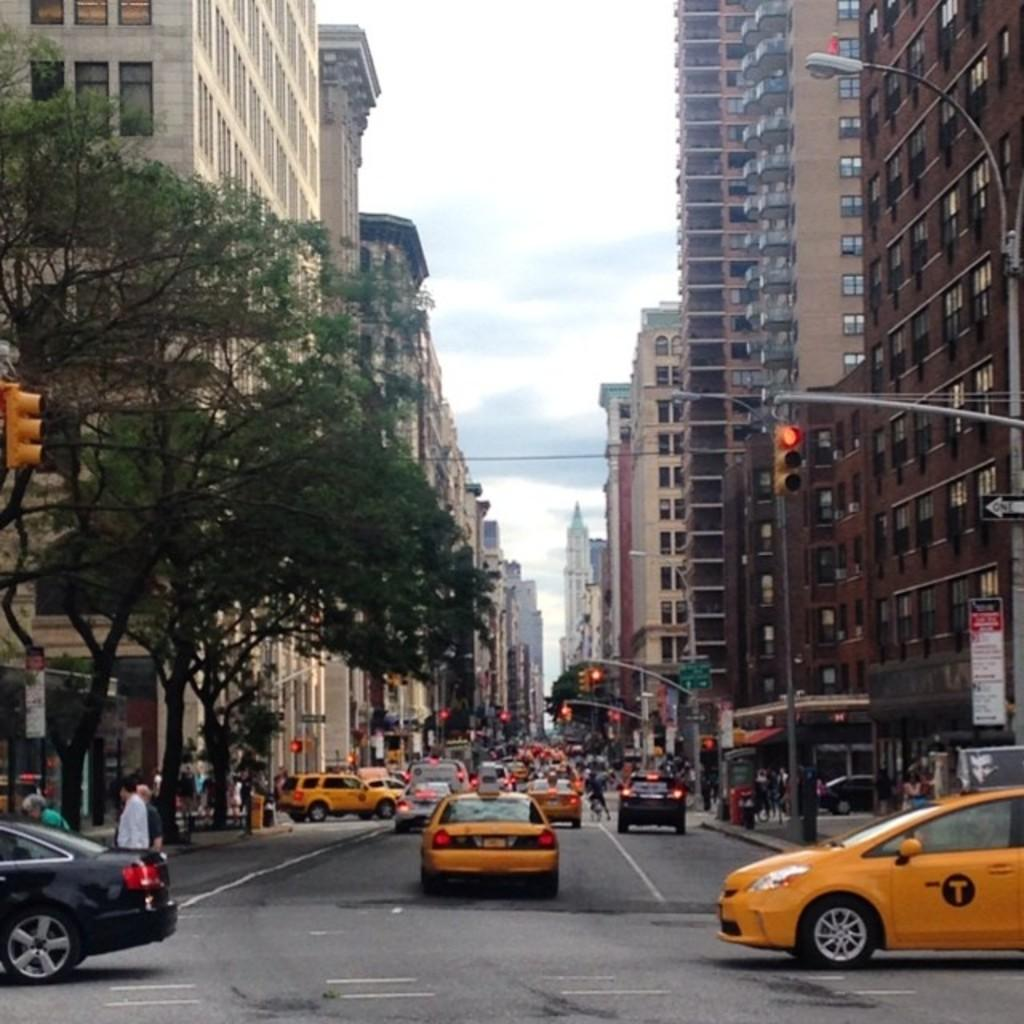What is happening on the road in the image? There are cars moving on the road in the image. What can be seen in the background of the image? There are many buildings in the image. What are the two people in the image doing? Two people are walking to the left in the image. Are there any islands visible in the image? There are no islands present in the image. What type of trucks can be seen driving on the road in the image? There are no trucks visible in the image; only cars are mentioned. 